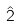Convert formula to latex. <formula><loc_0><loc_0><loc_500><loc_500>\hat { 2 }</formula> 